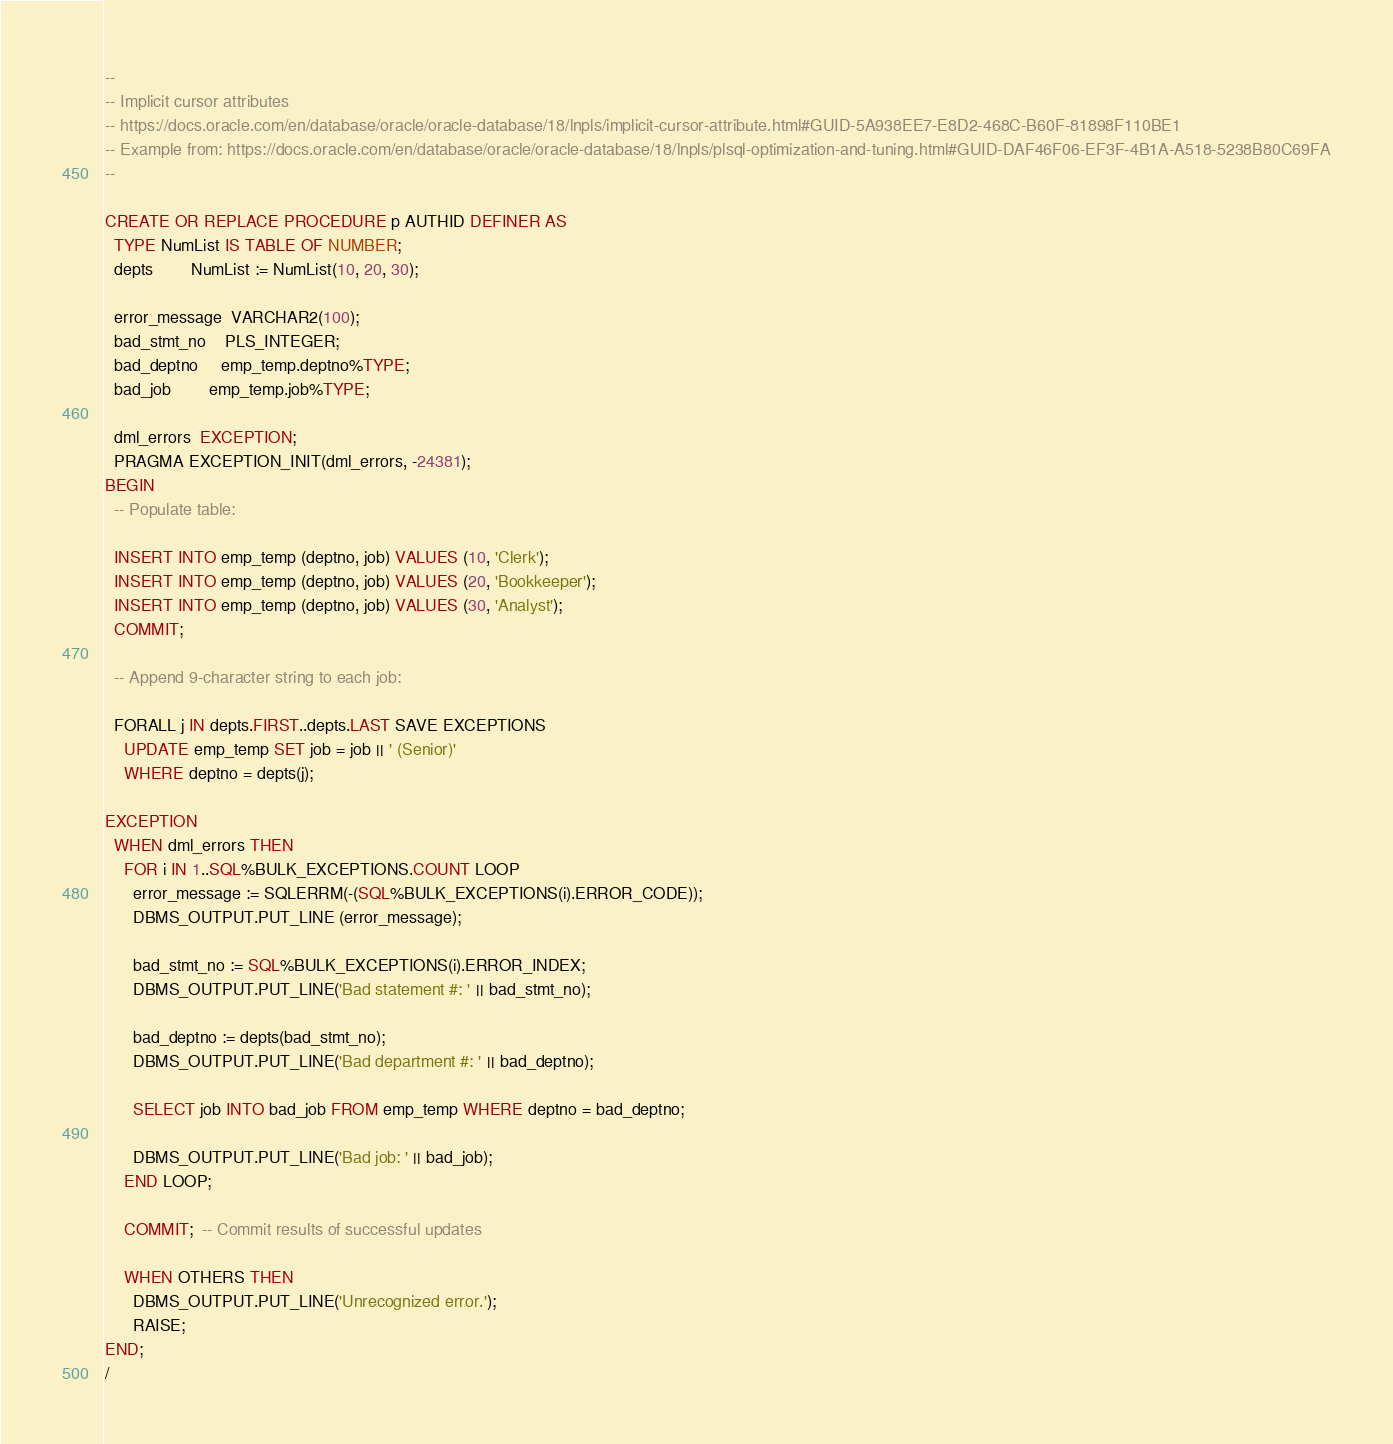<code> <loc_0><loc_0><loc_500><loc_500><_SQL_>--
-- Implicit cursor attributes
-- https://docs.oracle.com/en/database/oracle/oracle-database/18/lnpls/implicit-cursor-attribute.html#GUID-5A938EE7-E8D2-468C-B60F-81898F110BE1
-- Example from: https://docs.oracle.com/en/database/oracle/oracle-database/18/lnpls/plsql-optimization-and-tuning.html#GUID-DAF46F06-EF3F-4B1A-A518-5238B80C69FA
--

CREATE OR REPLACE PROCEDURE p AUTHID DEFINER AS
  TYPE NumList IS TABLE OF NUMBER;
  depts        NumList := NumList(10, 20, 30);
 
  error_message  VARCHAR2(100);
  bad_stmt_no    PLS_INTEGER;
  bad_deptno     emp_temp.deptno%TYPE;
  bad_job        emp_temp.job%TYPE;
 
  dml_errors  EXCEPTION;
  PRAGMA EXCEPTION_INIT(dml_errors, -24381);
BEGIN
  -- Populate table:
 
  INSERT INTO emp_temp (deptno, job) VALUES (10, 'Clerk');
  INSERT INTO emp_temp (deptno, job) VALUES (20, 'Bookkeeper');
  INSERT INTO emp_temp (deptno, job) VALUES (30, 'Analyst');
  COMMIT;
 
  -- Append 9-character string to each job:
 
  FORALL j IN depts.FIRST..depts.LAST SAVE EXCEPTIONS
    UPDATE emp_temp SET job = job || ' (Senior)'
    WHERE deptno = depts(j); 
 
EXCEPTION
  WHEN dml_errors THEN
    FOR i IN 1..SQL%BULK_EXCEPTIONS.COUNT LOOP
      error_message := SQLERRM(-(SQL%BULK_EXCEPTIONS(i).ERROR_CODE));
      DBMS_OUTPUT.PUT_LINE (error_message);
 
      bad_stmt_no := SQL%BULK_EXCEPTIONS(i).ERROR_INDEX;
      DBMS_OUTPUT.PUT_LINE('Bad statement #: ' || bad_stmt_no);
 
      bad_deptno := depts(bad_stmt_no);
      DBMS_OUTPUT.PUT_LINE('Bad department #: ' || bad_deptno);
 
      SELECT job INTO bad_job FROM emp_temp WHERE deptno = bad_deptno;
 
      DBMS_OUTPUT.PUT_LINE('Bad job: ' || bad_job);
    END LOOP;
 
    COMMIT;  -- Commit results of successful updates

    WHEN OTHERS THEN
      DBMS_OUTPUT.PUT_LINE('Unrecognized error.');
      RAISE;
END;
/</code> 